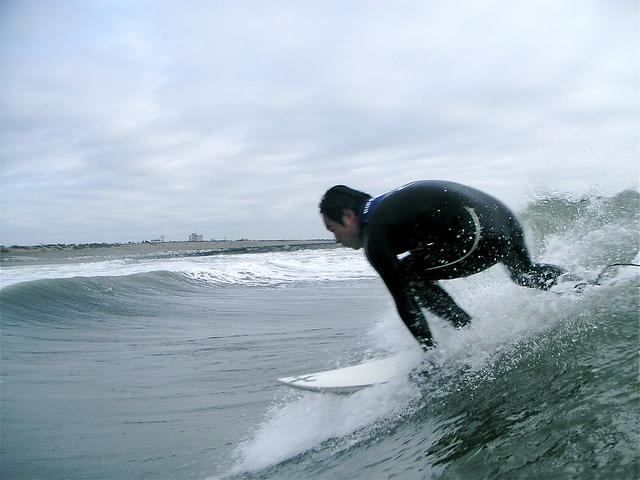What color is the surfboard?
Write a very short answer. White. What is the man wearing?
Short answer required. Wetsuit. What is he riding?
Write a very short answer. Surfboard. 